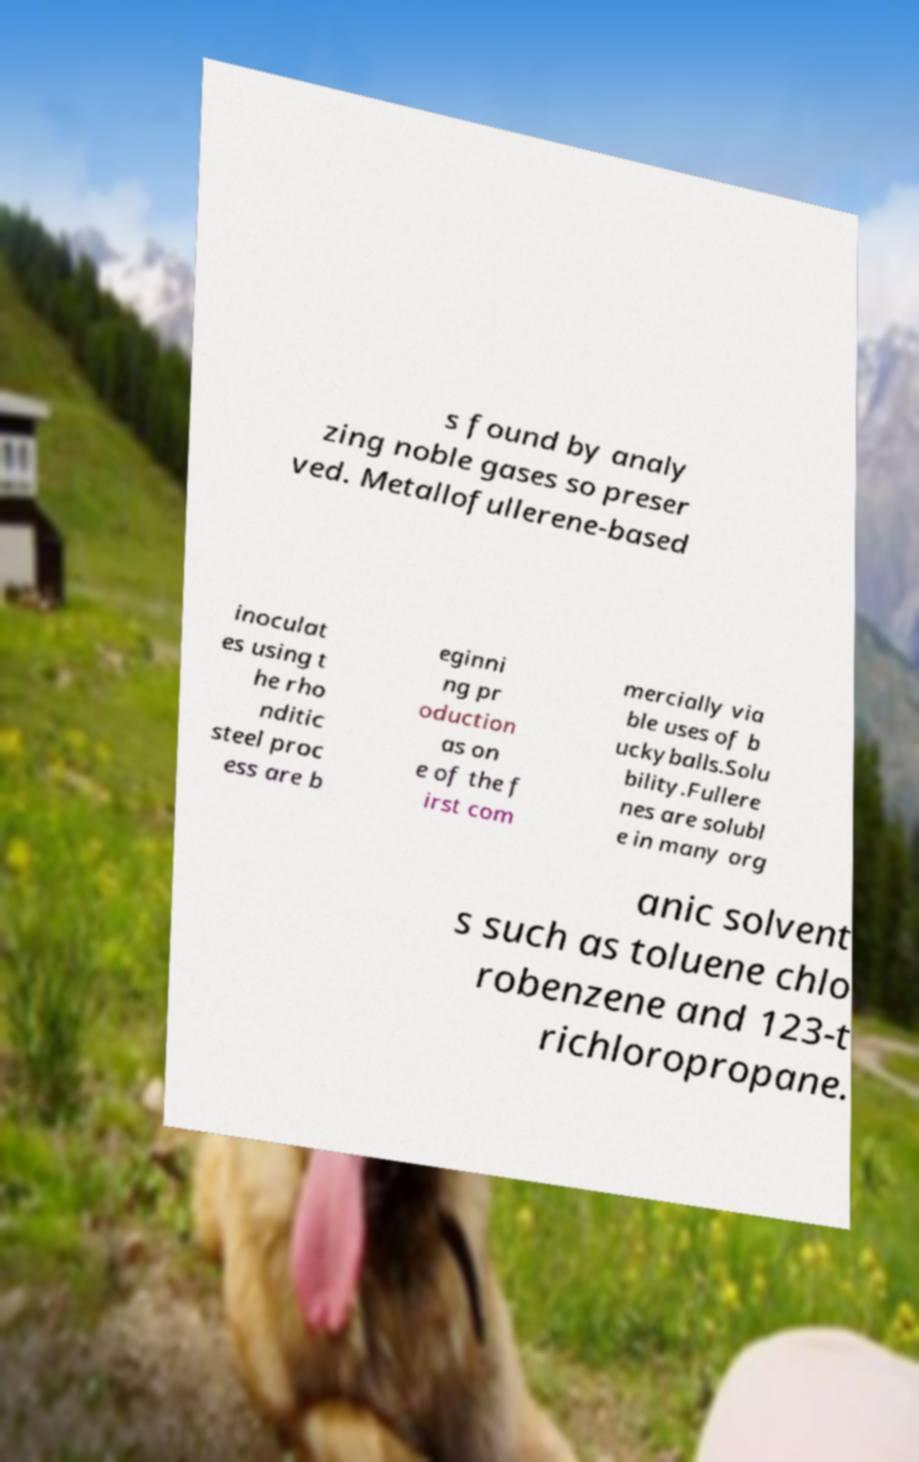Can you accurately transcribe the text from the provided image for me? s found by analy zing noble gases so preser ved. Metallofullerene-based inoculat es using t he rho nditic steel proc ess are b eginni ng pr oduction as on e of the f irst com mercially via ble uses of b uckyballs.Solu bility.Fullere nes are solubl e in many org anic solvent s such as toluene chlo robenzene and 123-t richloropropane. 